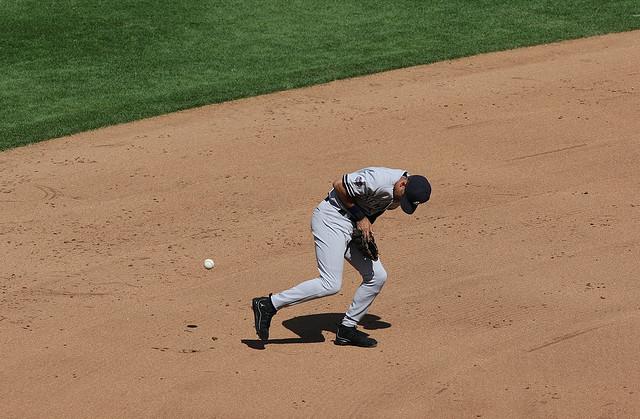How many people are present?
Answer briefly. 1. Is he a good player?
Short answer required. No. Is the baseball player hurt?
Be succinct. No. Is the player currently on offense or defense?
Short answer required. Defense. Where is the ball?
Give a very brief answer. In air. What sport is being played?
Concise answer only. Baseball. 